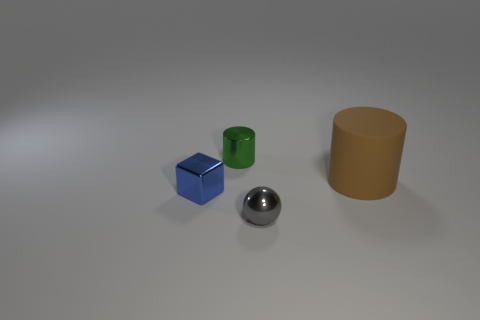Add 4 small objects. How many objects exist? 8 Subtract all balls. How many objects are left? 3 Subtract 0 cyan cylinders. How many objects are left? 4 Subtract all tiny gray shiny spheres. Subtract all small metallic cubes. How many objects are left? 2 Add 4 tiny blue metallic objects. How many tiny blue metallic objects are left? 5 Add 2 tiny brown rubber cylinders. How many tiny brown rubber cylinders exist? 2 